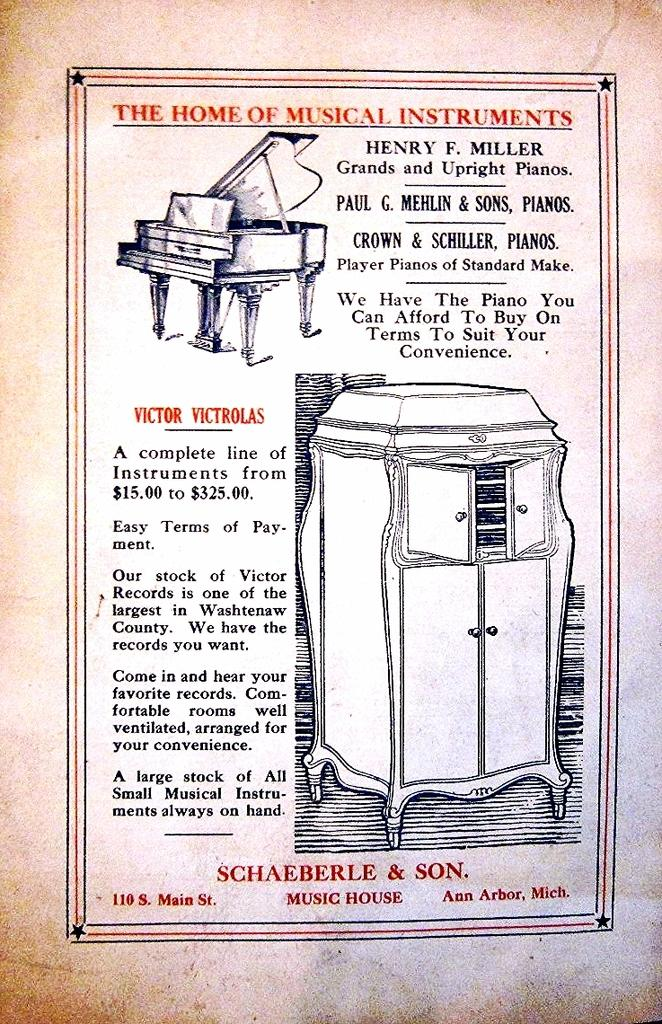What can be seen in the foreground of the image? In the foreground of the image, there is text, diagrams of a musical instrument, and a cupboard-like object. Can you describe the text in the image? Unfortunately, the details of the text cannot be determined from the provided facts. What type of musical instrument is depicted in the diagrams? The specific type of musical instrument cannot be determined from the provided facts. What is the purpose of the cupboard-like object in the image? The purpose of the cupboard-like object cannot be determined from the provided facts. How many goldfish are swimming in the cupboard-like object in the image? There are no goldfish present in the image; the cupboard-like object is not a fish tank or aquarium. What type of marble is used to decorate the musical instrument diagrams in the image? There is no mention of marble in the image or the provided facts. 